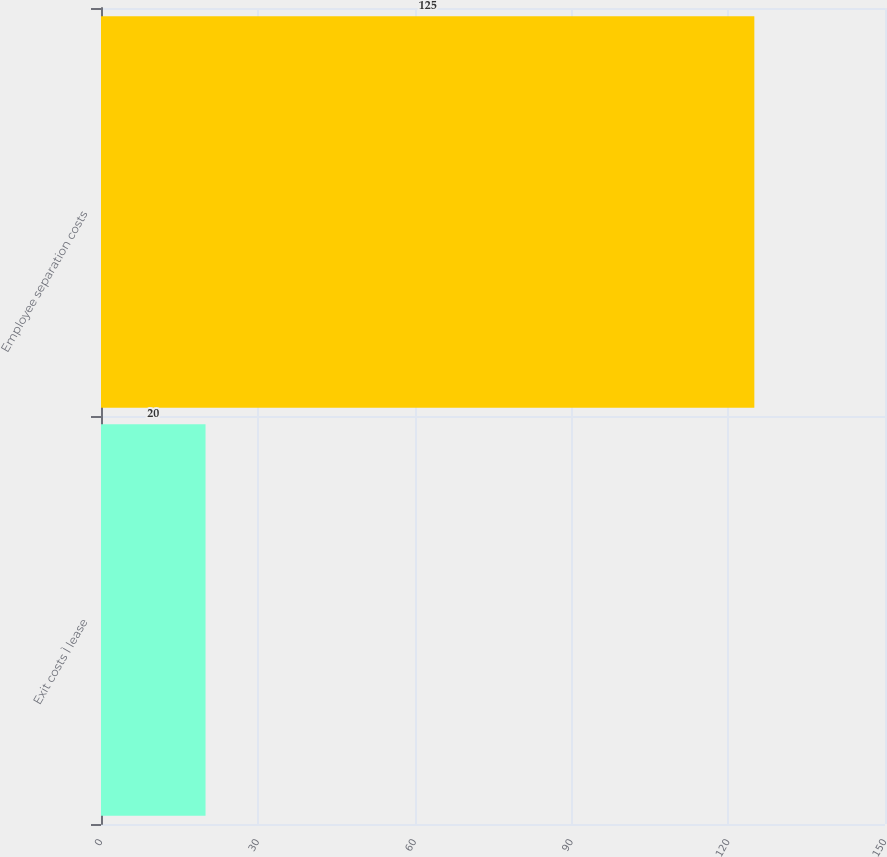Convert chart. <chart><loc_0><loc_0><loc_500><loc_500><bar_chart><fcel>Exit costs Ì lease<fcel>Employee separation costs<nl><fcel>20<fcel>125<nl></chart> 